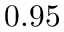Convert formula to latex. <formula><loc_0><loc_0><loc_500><loc_500>0 . 9 5</formula> 